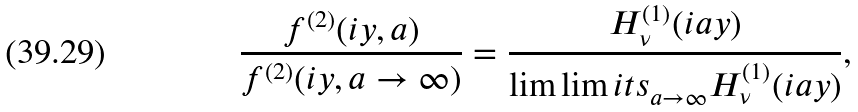<formula> <loc_0><loc_0><loc_500><loc_500>\frac { f ^ { ( 2 ) } ( i y , a ) } { f ^ { ( 2 ) } ( i y , a \to \infty ) } = \frac { H _ { \nu } ^ { ( 1 ) } ( i a y ) } { \lim \lim i t s _ { a \to \infty } H _ { \nu } ^ { ( 1 ) } ( i a y ) } ,</formula> 